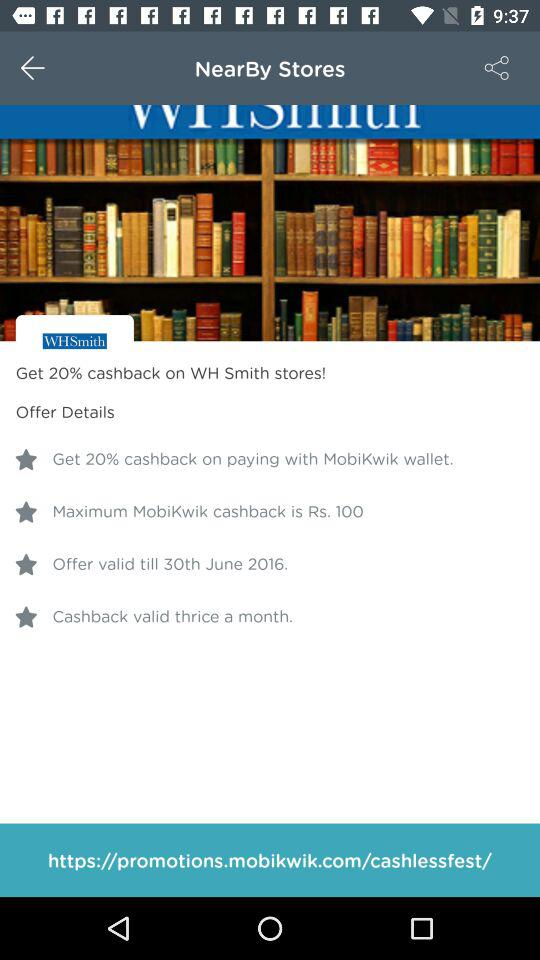What's the offer valid date? The offer is valid until 30th June 2016. 